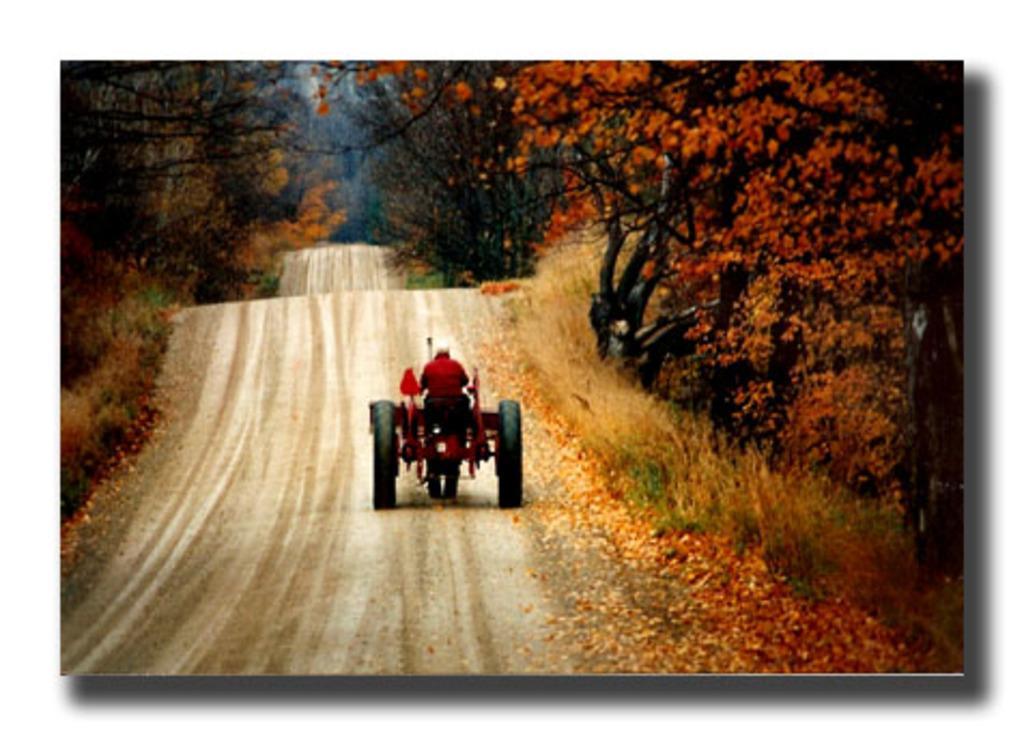Can you describe this image briefly? In this image I can see the road, some grass, few leaves which are orange in color on the road, a person in a vehicle and few trees on both sides of the road which are black, orange and green in color. 